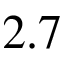Convert formula to latex. <formula><loc_0><loc_0><loc_500><loc_500>2 . 7</formula> 